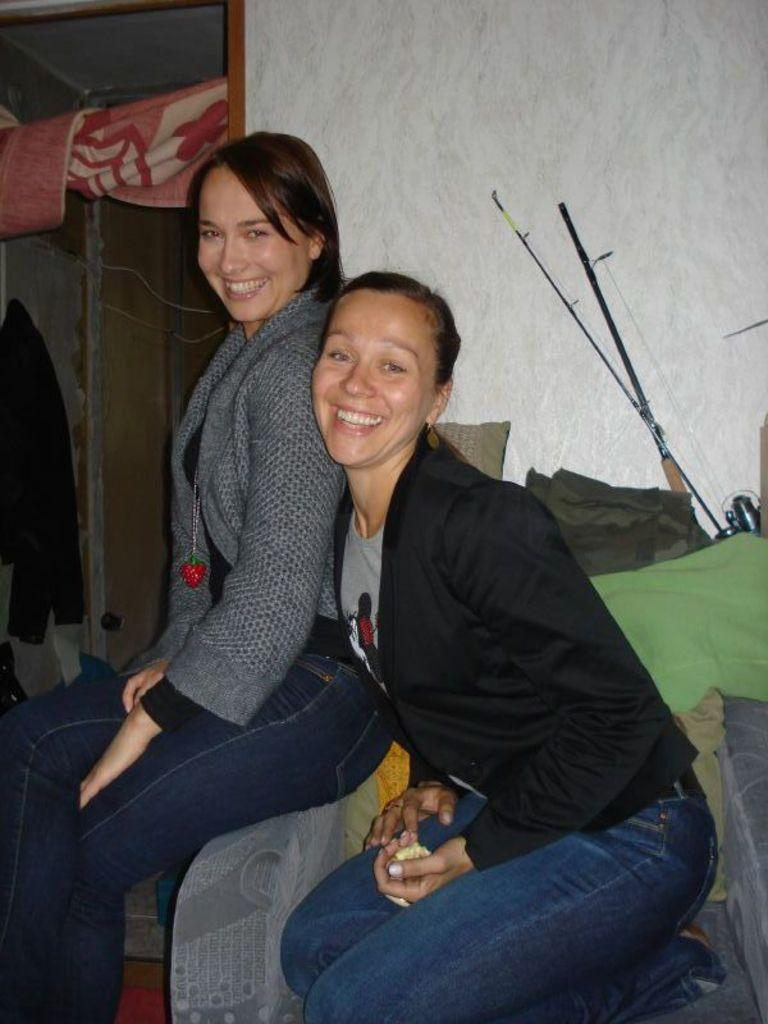How many women are in the image? There are two women in the image. What are the women doing in the image? The women are sitting on a chair in the image. What can be seen hanging on the door in the image? There are clothes on the door in the image. What type of structure is visible in the image? There is a wall visible in the image. What type of meat is hanging from the wall in the image? There is no meat hanging from the wall in the image; only clothes are visible on the door. How many knots are tied on the sticks in the image? There are no knots on the sticks in the image; only sticks are visible. 